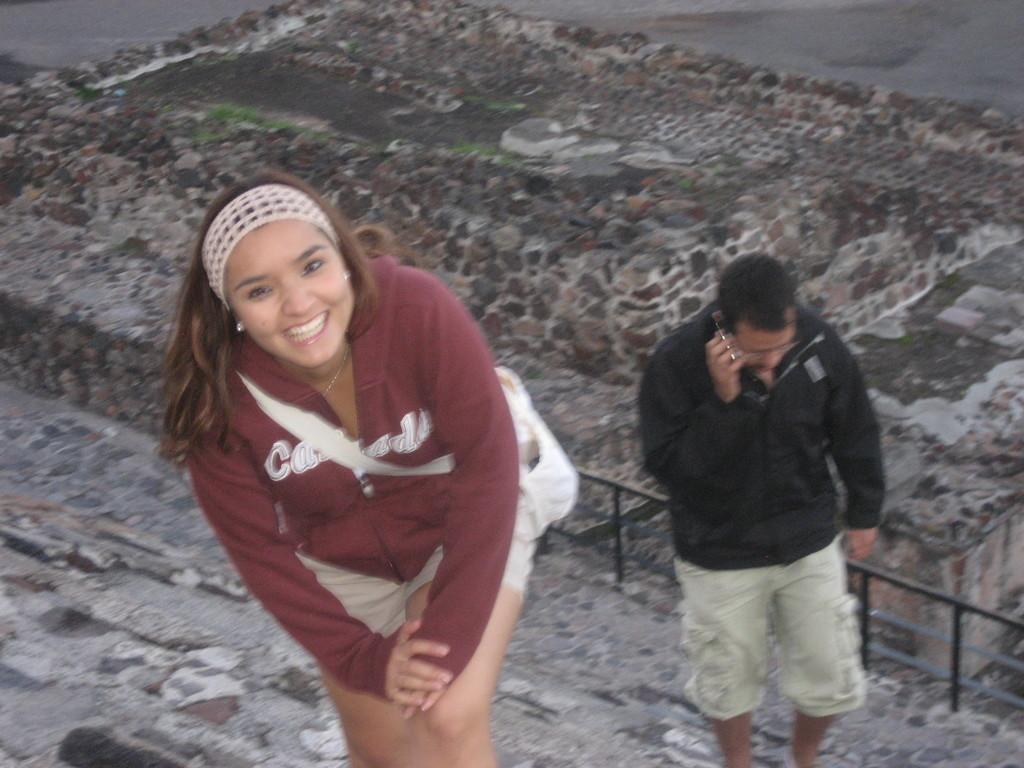Who are the people in the image? There is a man and a woman in the image. Where are they standing? They are standing on a staircase. What is the man holding? The man is holding a device. What can be seen in the background of the image? There is a fence in the image. What type of natural environment is visible in the image? There is grass visible in the image. Reasoning: Let's think step by step by step in order to produce the conversation. We start by identifying the main subjects in the image, which are the man and the woman. Then, we describe their location and actions, noting that they are standing on a staircase and the man is holding a device. Next, we mention the background elements, such as the fence. Finally, we describe the natural environment visible in the image, which is grass. Absurd Question/Answer: What type of surprise can be seen in the image? There is no surprise present in the image. What type of stitch is being used to repair the fence in the image? There is no stitching or repair work visible on the fence in the image. 